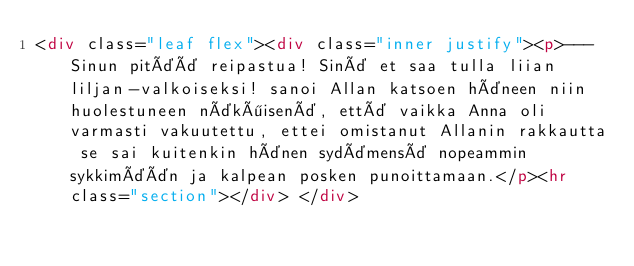<code> <loc_0><loc_0><loc_500><loc_500><_HTML_><div class="leaf flex"><div class="inner justify"><p>--- Sinun pitää reipastua! Sinä et saa tulla liian liljan-valkoiseksi! sanoi Allan katsoen häneen niin huolestuneen näköisenä, että vaikka Anna oli varmasti vakuutettu, ettei omistanut Allanin rakkautta se sai kuitenkin hänen sydämensä nopeammin sykkimään ja kalpean posken punoittamaan.</p><hr class="section"></div> </div></code> 